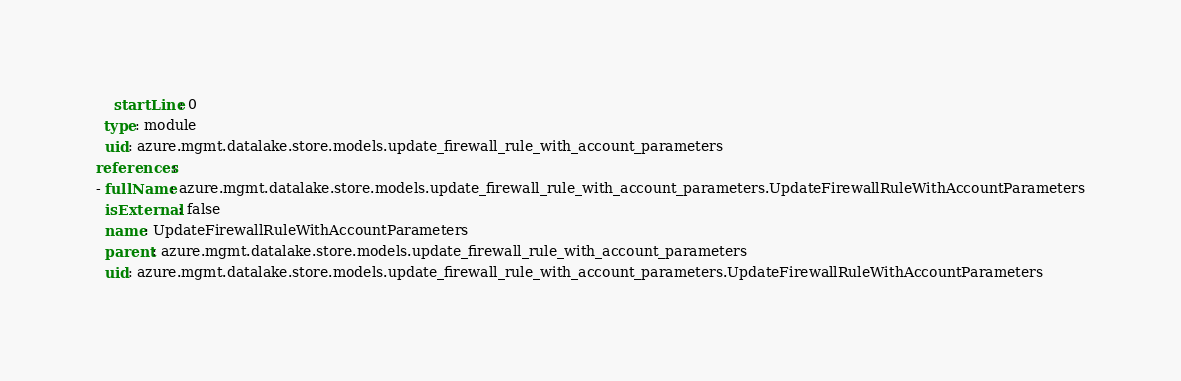Convert code to text. <code><loc_0><loc_0><loc_500><loc_500><_YAML_>    startLine: 0
  type: module
  uid: azure.mgmt.datalake.store.models.update_firewall_rule_with_account_parameters
references:
- fullName: azure.mgmt.datalake.store.models.update_firewall_rule_with_account_parameters.UpdateFirewallRuleWithAccountParameters
  isExternal: false
  name: UpdateFirewallRuleWithAccountParameters
  parent: azure.mgmt.datalake.store.models.update_firewall_rule_with_account_parameters
  uid: azure.mgmt.datalake.store.models.update_firewall_rule_with_account_parameters.UpdateFirewallRuleWithAccountParameters
</code> 